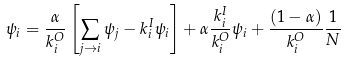<formula> <loc_0><loc_0><loc_500><loc_500>\psi _ { i } = \frac { \alpha } { k ^ { O } _ { i } } \left [ \sum _ { j \rightarrow i } \psi _ { j } - k ^ { I } _ { i } \psi _ { i } \right ] + \alpha \frac { k ^ { I } _ { i } } { k ^ { O } _ { i } } \psi _ { i } + \frac { ( 1 - \alpha ) } { k ^ { O } _ { i } } \frac { 1 } { N }</formula> 